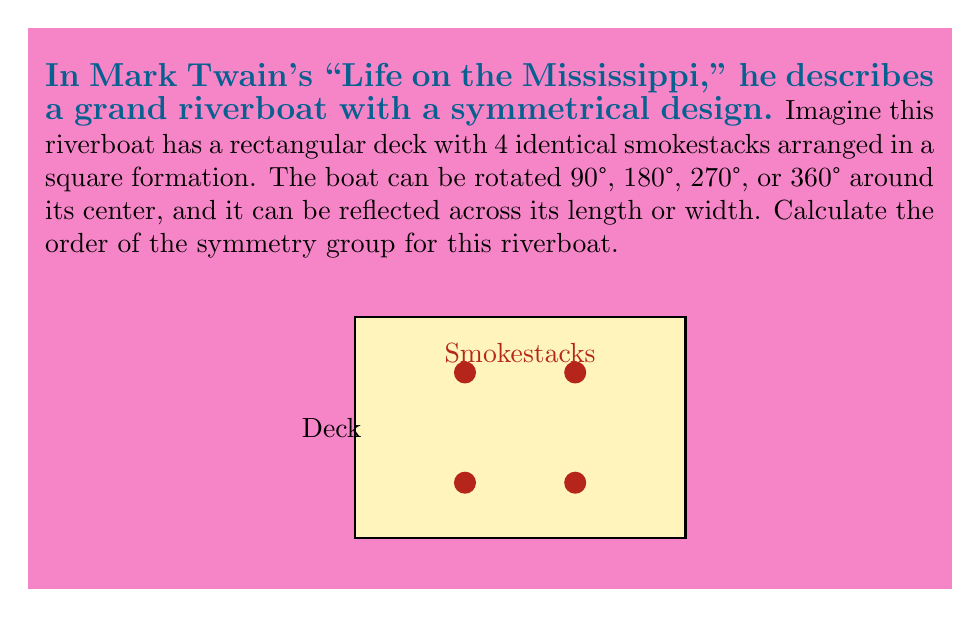Can you answer this question? To solve this problem, we need to identify all the symmetries of the riverboat and count them. Let's approach this step-by-step:

1) Rotational symmetries:
   - 0° (identity)
   - 90° clockwise
   - 180°
   - 270° clockwise (or 90° counterclockwise)

2) Reflection symmetries:
   - Across the length (horizontal axis)
   - Across the width (vertical axis)
   - Across the two diagonals

3) The symmetry group of this riverboat is actually the dihedral group $D_4$, which is the symmetry group of a square.

4) The order of a dihedral group $D_n$ is given by the formula:

   $$ |D_n| = 2n $$

5) In this case, $n = 4$ (as we have 4 rotational symmetries), so:

   $$ |D_4| = 2 \cdot 4 = 8 $$

Therefore, the order of the symmetry group for this riverboat is 8.
Answer: 8 